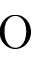<formula> <loc_0><loc_0><loc_500><loc_500>O</formula> 